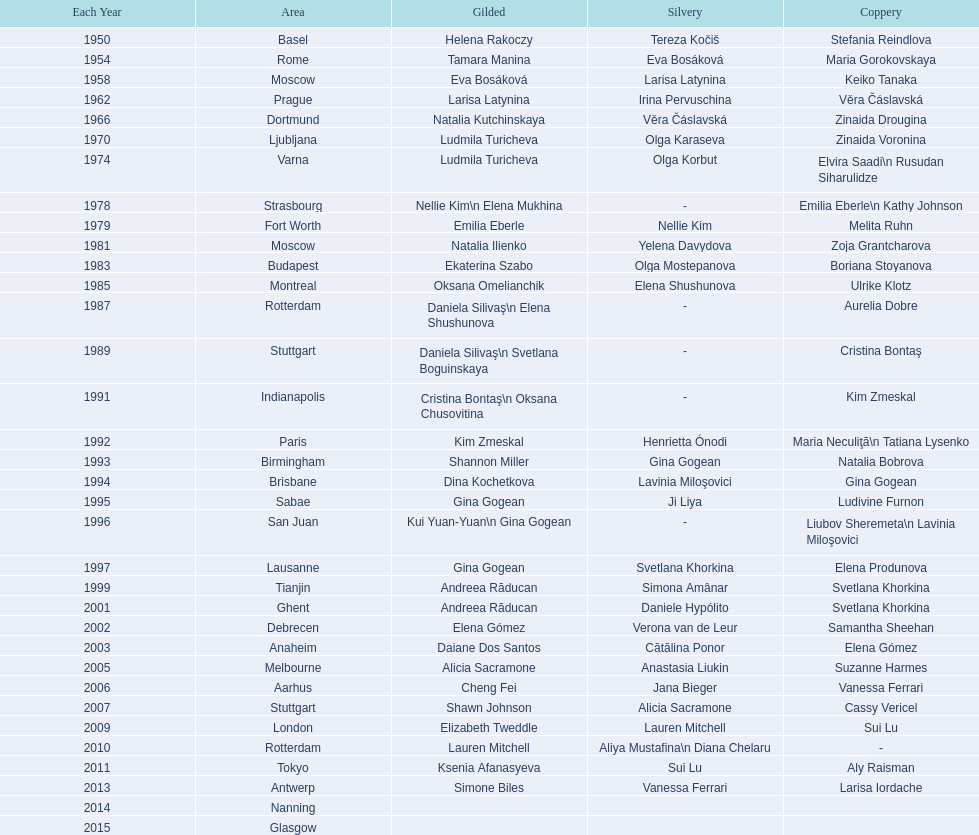In which location were the championships held before taking place in prague in 1962? Moscow. Would you be able to parse every entry in this table? {'header': ['Each Year', 'Area', 'Gilded', 'Silvery', 'Coppery'], 'rows': [['1950', 'Basel', 'Helena Rakoczy', 'Tereza Kočiš', 'Stefania Reindlova'], ['1954', 'Rome', 'Tamara Manina', 'Eva Bosáková', 'Maria Gorokovskaya'], ['1958', 'Moscow', 'Eva Bosáková', 'Larisa Latynina', 'Keiko Tanaka'], ['1962', 'Prague', 'Larisa Latynina', 'Irina Pervuschina', 'Věra Čáslavská'], ['1966', 'Dortmund', 'Natalia Kutchinskaya', 'Věra Čáslavská', 'Zinaida Drougina'], ['1970', 'Ljubljana', 'Ludmila Turicheva', 'Olga Karaseva', 'Zinaida Voronina'], ['1974', 'Varna', 'Ludmila Turicheva', 'Olga Korbut', 'Elvira Saadi\\n Rusudan Siharulidze'], ['1978', 'Strasbourg', 'Nellie Kim\\n Elena Mukhina', '-', 'Emilia Eberle\\n Kathy Johnson'], ['1979', 'Fort Worth', 'Emilia Eberle', 'Nellie Kim', 'Melita Ruhn'], ['1981', 'Moscow', 'Natalia Ilienko', 'Yelena Davydova', 'Zoja Grantcharova'], ['1983', 'Budapest', 'Ekaterina Szabo', 'Olga Mostepanova', 'Boriana Stoyanova'], ['1985', 'Montreal', 'Oksana Omelianchik', 'Elena Shushunova', 'Ulrike Klotz'], ['1987', 'Rotterdam', 'Daniela Silivaş\\n Elena Shushunova', '-', 'Aurelia Dobre'], ['1989', 'Stuttgart', 'Daniela Silivaş\\n Svetlana Boguinskaya', '-', 'Cristina Bontaş'], ['1991', 'Indianapolis', 'Cristina Bontaş\\n Oksana Chusovitina', '-', 'Kim Zmeskal'], ['1992', 'Paris', 'Kim Zmeskal', 'Henrietta Ónodi', 'Maria Neculiţă\\n Tatiana Lysenko'], ['1993', 'Birmingham', 'Shannon Miller', 'Gina Gogean', 'Natalia Bobrova'], ['1994', 'Brisbane', 'Dina Kochetkova', 'Lavinia Miloşovici', 'Gina Gogean'], ['1995', 'Sabae', 'Gina Gogean', 'Ji Liya', 'Ludivine Furnon'], ['1996', 'San Juan', 'Kui Yuan-Yuan\\n Gina Gogean', '-', 'Liubov Sheremeta\\n Lavinia Miloşovici'], ['1997', 'Lausanne', 'Gina Gogean', 'Svetlana Khorkina', 'Elena Produnova'], ['1999', 'Tianjin', 'Andreea Răducan', 'Simona Amânar', 'Svetlana Khorkina'], ['2001', 'Ghent', 'Andreea Răducan', 'Daniele Hypólito', 'Svetlana Khorkina'], ['2002', 'Debrecen', 'Elena Gómez', 'Verona van de Leur', 'Samantha Sheehan'], ['2003', 'Anaheim', 'Daiane Dos Santos', 'Cătălina Ponor', 'Elena Gómez'], ['2005', 'Melbourne', 'Alicia Sacramone', 'Anastasia Liukin', 'Suzanne Harmes'], ['2006', 'Aarhus', 'Cheng Fei', 'Jana Bieger', 'Vanessa Ferrari'], ['2007', 'Stuttgart', 'Shawn Johnson', 'Alicia Sacramone', 'Cassy Vericel'], ['2009', 'London', 'Elizabeth Tweddle', 'Lauren Mitchell', 'Sui Lu'], ['2010', 'Rotterdam', 'Lauren Mitchell', 'Aliya Mustafina\\n Diana Chelaru', '-'], ['2011', 'Tokyo', 'Ksenia Afanasyeva', 'Sui Lu', 'Aly Raisman'], ['2013', 'Antwerp', 'Simone Biles', 'Vanessa Ferrari', 'Larisa Iordache'], ['2014', 'Nanning', '', '', ''], ['2015', 'Glasgow', '', '', '']]} 